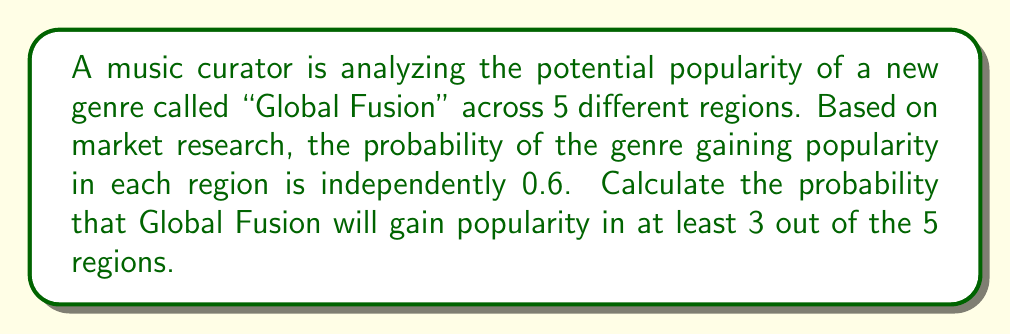Teach me how to tackle this problem. Let's approach this step-by-step:

1) This is a binomial probability problem. We have:
   - n = 5 (number of regions)
   - p = 0.6 (probability of success in each region)
   - We want the probability of 3 or more successes

2) The probability of at least 3 successes is the sum of the probabilities of exactly 3, 4, and 5 successes.

3) The binomial probability formula is:

   $$P(X = k) = \binom{n}{k} p^k (1-p)^{n-k}$$

   where $\binom{n}{k}$ is the binomial coefficient.

4) Let's calculate for each case:

   For 3 successes:
   $$P(X = 3) = \binom{5}{3} (0.6)^3 (0.4)^2 = 10 \cdot 0.216 \cdot 0.16 = 0.3456$$

   For 4 successes:
   $$P(X = 4) = \binom{5}{4} (0.6)^4 (0.4)^1 = 5 \cdot 0.1296 \cdot 0.4 = 0.2592$$

   For 5 successes:
   $$P(X = 5) = \binom{5}{5} (0.6)^5 (0.4)^0 = 1 \cdot 0.07776 \cdot 1 = 0.07776$$

5) The total probability is the sum of these:

   $$P(X \geq 3) = 0.3456 + 0.2592 + 0.07776 = 0.68256$$
Answer: 0.68256 